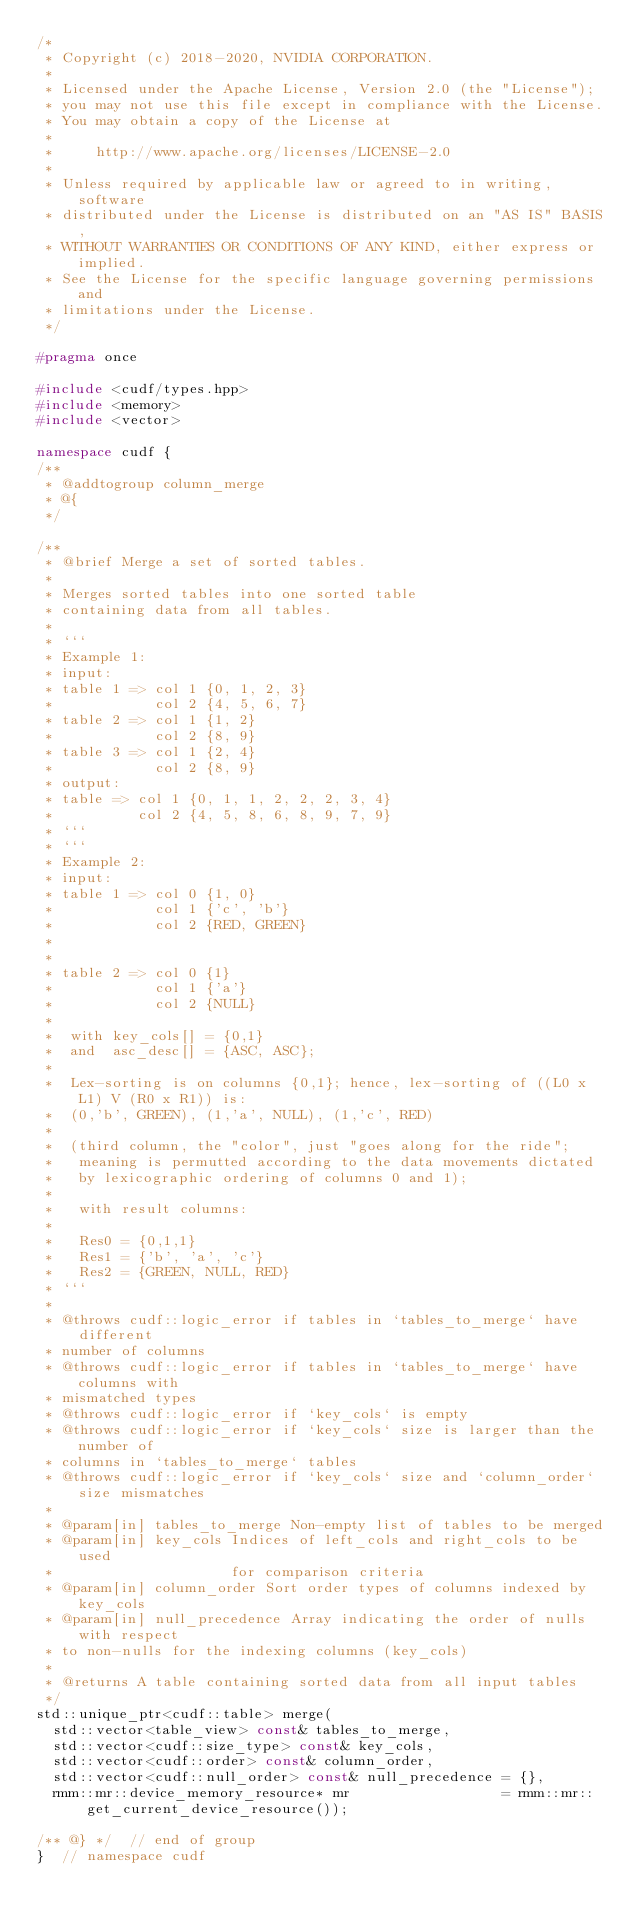Convert code to text. <code><loc_0><loc_0><loc_500><loc_500><_C++_>/*
 * Copyright (c) 2018-2020, NVIDIA CORPORATION.
 *
 * Licensed under the Apache License, Version 2.0 (the "License");
 * you may not use this file except in compliance with the License.
 * You may obtain a copy of the License at
 *
 *     http://www.apache.org/licenses/LICENSE-2.0
 *
 * Unless required by applicable law or agreed to in writing, software
 * distributed under the License is distributed on an "AS IS" BASIS,
 * WITHOUT WARRANTIES OR CONDITIONS OF ANY KIND, either express or implied.
 * See the License for the specific language governing permissions and
 * limitations under the License.
 */

#pragma once

#include <cudf/types.hpp>
#include <memory>
#include <vector>

namespace cudf {
/**
 * @addtogroup column_merge
 * @{
 */

/**
 * @brief Merge a set of sorted tables.
 *
 * Merges sorted tables into one sorted table
 * containing data from all tables.
 *
 * ```
 * Example 1:
 * input:
 * table 1 => col 1 {0, 1, 2, 3}
 *            col 2 {4, 5, 6, 7}
 * table 2 => col 1 {1, 2}
 *            col 2 {8, 9}
 * table 3 => col 1 {2, 4}
 *            col 2 {8, 9}
 * output:
 * table => col 1 {0, 1, 1, 2, 2, 2, 3, 4}
 *          col 2 {4, 5, 8, 6, 8, 9, 7, 9}
 * ```
 * ```
 * Example 2:
 * input:
 * table 1 => col 0 {1, 0}
 *            col 1 {'c', 'b'}
 *            col 2 {RED, GREEN}
 *
 *
 * table 2 => col 0 {1}
 *            col 1 {'a'}
 *            col 2 {NULL}
 *
 *  with key_cols[] = {0,1}
 *  and  asc_desc[] = {ASC, ASC};
 *
 *  Lex-sorting is on columns {0,1}; hence, lex-sorting of ((L0 x L1) V (R0 x R1)) is:
 *  (0,'b', GREEN), (1,'a', NULL), (1,'c', RED)
 *
 *  (third column, the "color", just "goes along for the ride";
 *   meaning is permutted according to the data movements dictated
 *   by lexicographic ordering of columns 0 and 1);
 *
 *   with result columns:
 *
 *   Res0 = {0,1,1}
 *   Res1 = {'b', 'a', 'c'}
 *   Res2 = {GREEN, NULL, RED}
 * ```
 *
 * @throws cudf::logic_error if tables in `tables_to_merge` have different
 * number of columns
 * @throws cudf::logic_error if tables in `tables_to_merge` have columns with
 * mismatched types
 * @throws cudf::logic_error if `key_cols` is empty
 * @throws cudf::logic_error if `key_cols` size is larger than the number of
 * columns in `tables_to_merge` tables
 * @throws cudf::logic_error if `key_cols` size and `column_order` size mismatches
 *
 * @param[in] tables_to_merge Non-empty list of tables to be merged
 * @param[in] key_cols Indices of left_cols and right_cols to be used
 *                     for comparison criteria
 * @param[in] column_order Sort order types of columns indexed by key_cols
 * @param[in] null_precedence Array indicating the order of nulls with respect
 * to non-nulls for the indexing columns (key_cols)
 *
 * @returns A table containing sorted data from all input tables
 */
std::unique_ptr<cudf::table> merge(
  std::vector<table_view> const& tables_to_merge,
  std::vector<cudf::size_type> const& key_cols,
  std::vector<cudf::order> const& column_order,
  std::vector<cudf::null_order> const& null_precedence = {},
  rmm::mr::device_memory_resource* mr                  = rmm::mr::get_current_device_resource());

/** @} */  // end of group
}  // namespace cudf
</code> 